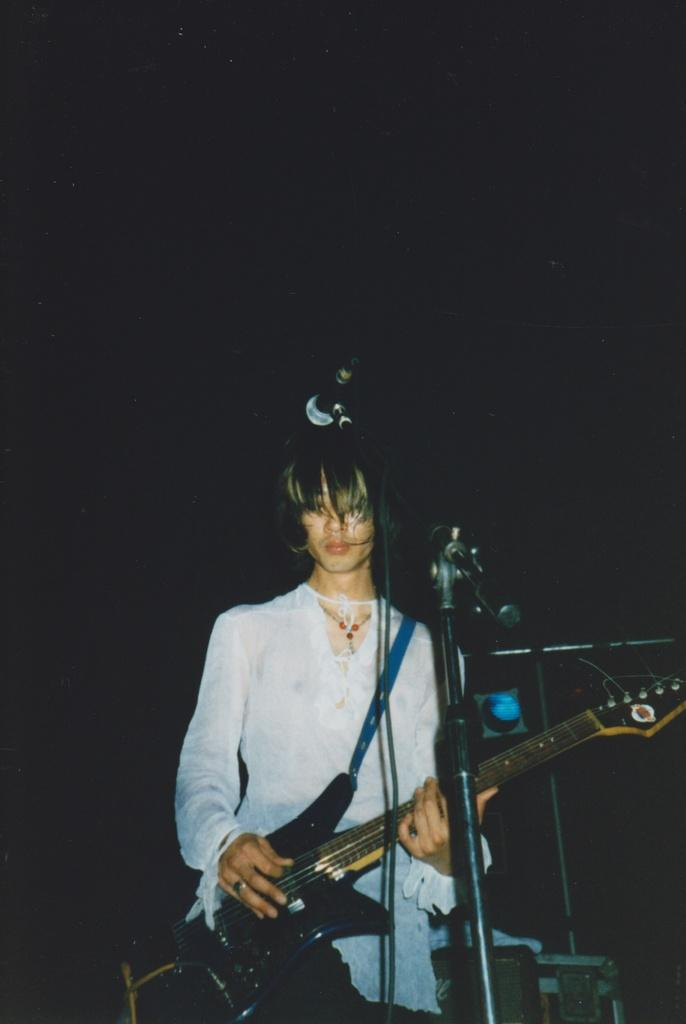What is the person in the image wearing? The person is wearing a white dress. What object is the person holding in the image? The person is holding a guitar. What is the person standing in front of in the image? The person is standing in front of a microphone. What color is the background of the image? The background of the image is black. What month is it in the image? The month is not mentioned or depicted in the image, so it cannot be determined. 